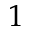<formula> <loc_0><loc_0><loc_500><loc_500>1</formula> 